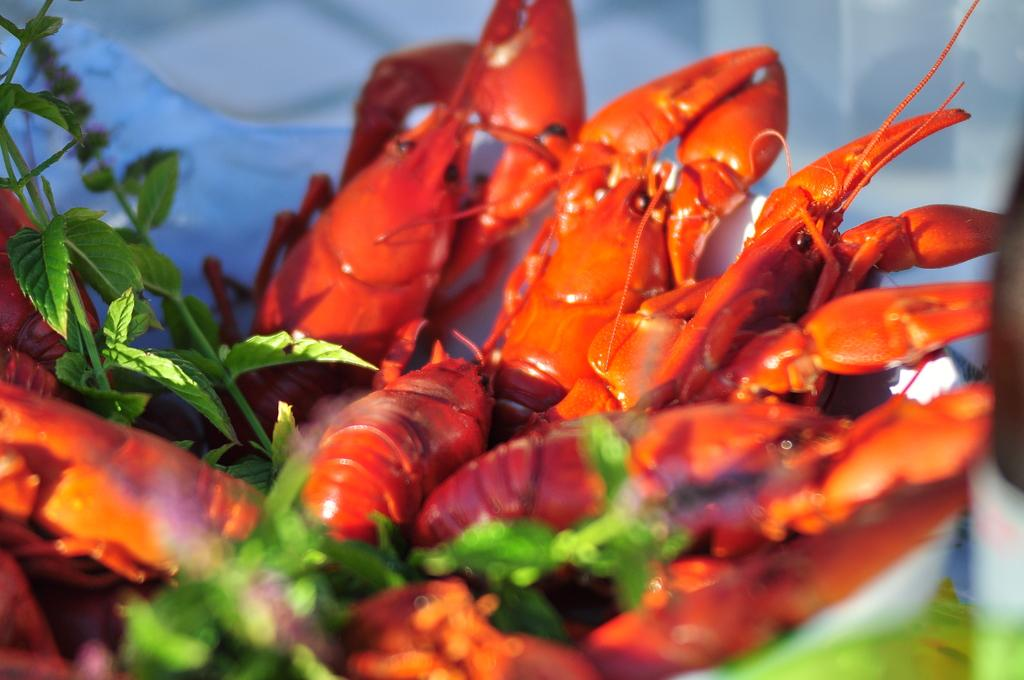What type of seafood can be seen in the image? There are lobsters in the image. What type of vegetation is present in the image? There are green leaves in the image. Where are the lobsters and green leaves located? The lobsters and green leaves are in a bowl. Can you describe the background of the image? The background of the image is slightly blurred. How does the leaf rub against the lobster in the image? There is no interaction between the lobster and the leaf in the image; they are simply in the same bowl. 